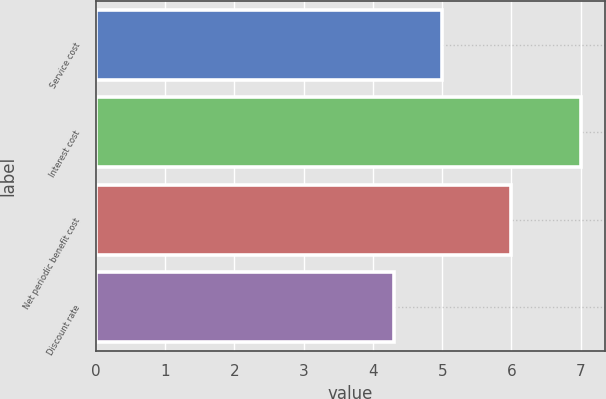<chart> <loc_0><loc_0><loc_500><loc_500><bar_chart><fcel>Service cost<fcel>Interest cost<fcel>Net periodic benefit cost<fcel>Discount rate<nl><fcel>5<fcel>7<fcel>6<fcel>4.3<nl></chart> 